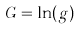Convert formula to latex. <formula><loc_0><loc_0><loc_500><loc_500>G = \ln ( g )</formula> 